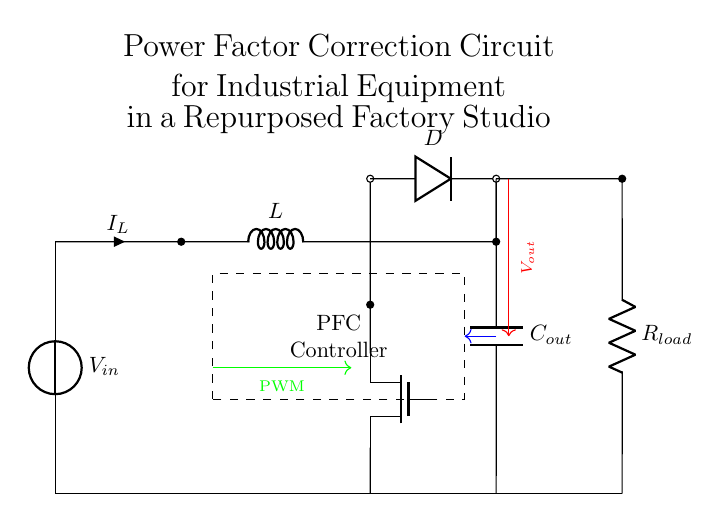What is the input voltage of the circuit? The input voltage is denoted as \( V_{in} \) in the circuit diagram, indicating it is the voltage supplied to the circuit.
Answer: \( V_{in} \) What component is used for power factor correction? The component responsible for power factor correction is the PFC Controller, which is highlighted by a dashed rectangle in the circuit.
Answer: PFC Controller What is the function of the diode in this circuit? The diode, labeled as \( D \), allows current to flow in one direction, ensuring that the output capacitor \( C_{out} \) is charged properly, thus preventing reverse current flow.
Answer: Rectification What is the role of the inductor? The inductor \( L \) helps to smooth out the current flowing in the circuit and contributes to energy storage by opposing changes in current, thus assisting in the power factor correction process.
Answer: Energy storage How does the PWM signal affect the circuit? The PWM signal controls the MOSFET, modulating its on-off state to regulate the output voltage \( V_{out} \) and optimize the power factor by adjusting the energy provided to the load.
Answer: Voltage regulation What is the output voltage connected to? The output voltage \( V_{out} \) is connected to the load resistor \( R_{load} \), which is where the actual work is done in terms of utilizing the electrical energy.
Answer: Load resistor What kind of switch is used in this circuit? The circuit utilizes a MOSFET, indicated as \( Tnmos \), which acts as a switch in power conversion and control for the output voltage to enhance energy efficiency.
Answer: MOSFET 